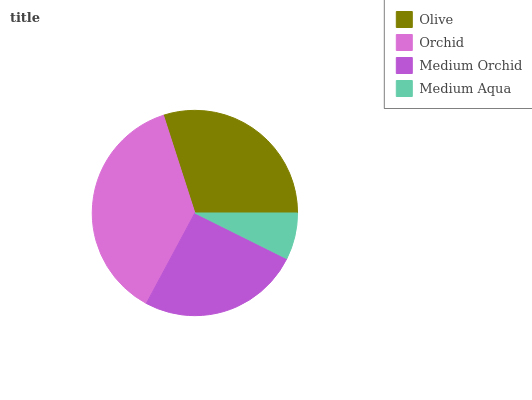Is Medium Aqua the minimum?
Answer yes or no. Yes. Is Orchid the maximum?
Answer yes or no. Yes. Is Medium Orchid the minimum?
Answer yes or no. No. Is Medium Orchid the maximum?
Answer yes or no. No. Is Orchid greater than Medium Orchid?
Answer yes or no. Yes. Is Medium Orchid less than Orchid?
Answer yes or no. Yes. Is Medium Orchid greater than Orchid?
Answer yes or no. No. Is Orchid less than Medium Orchid?
Answer yes or no. No. Is Olive the high median?
Answer yes or no. Yes. Is Medium Orchid the low median?
Answer yes or no. Yes. Is Medium Aqua the high median?
Answer yes or no. No. Is Olive the low median?
Answer yes or no. No. 